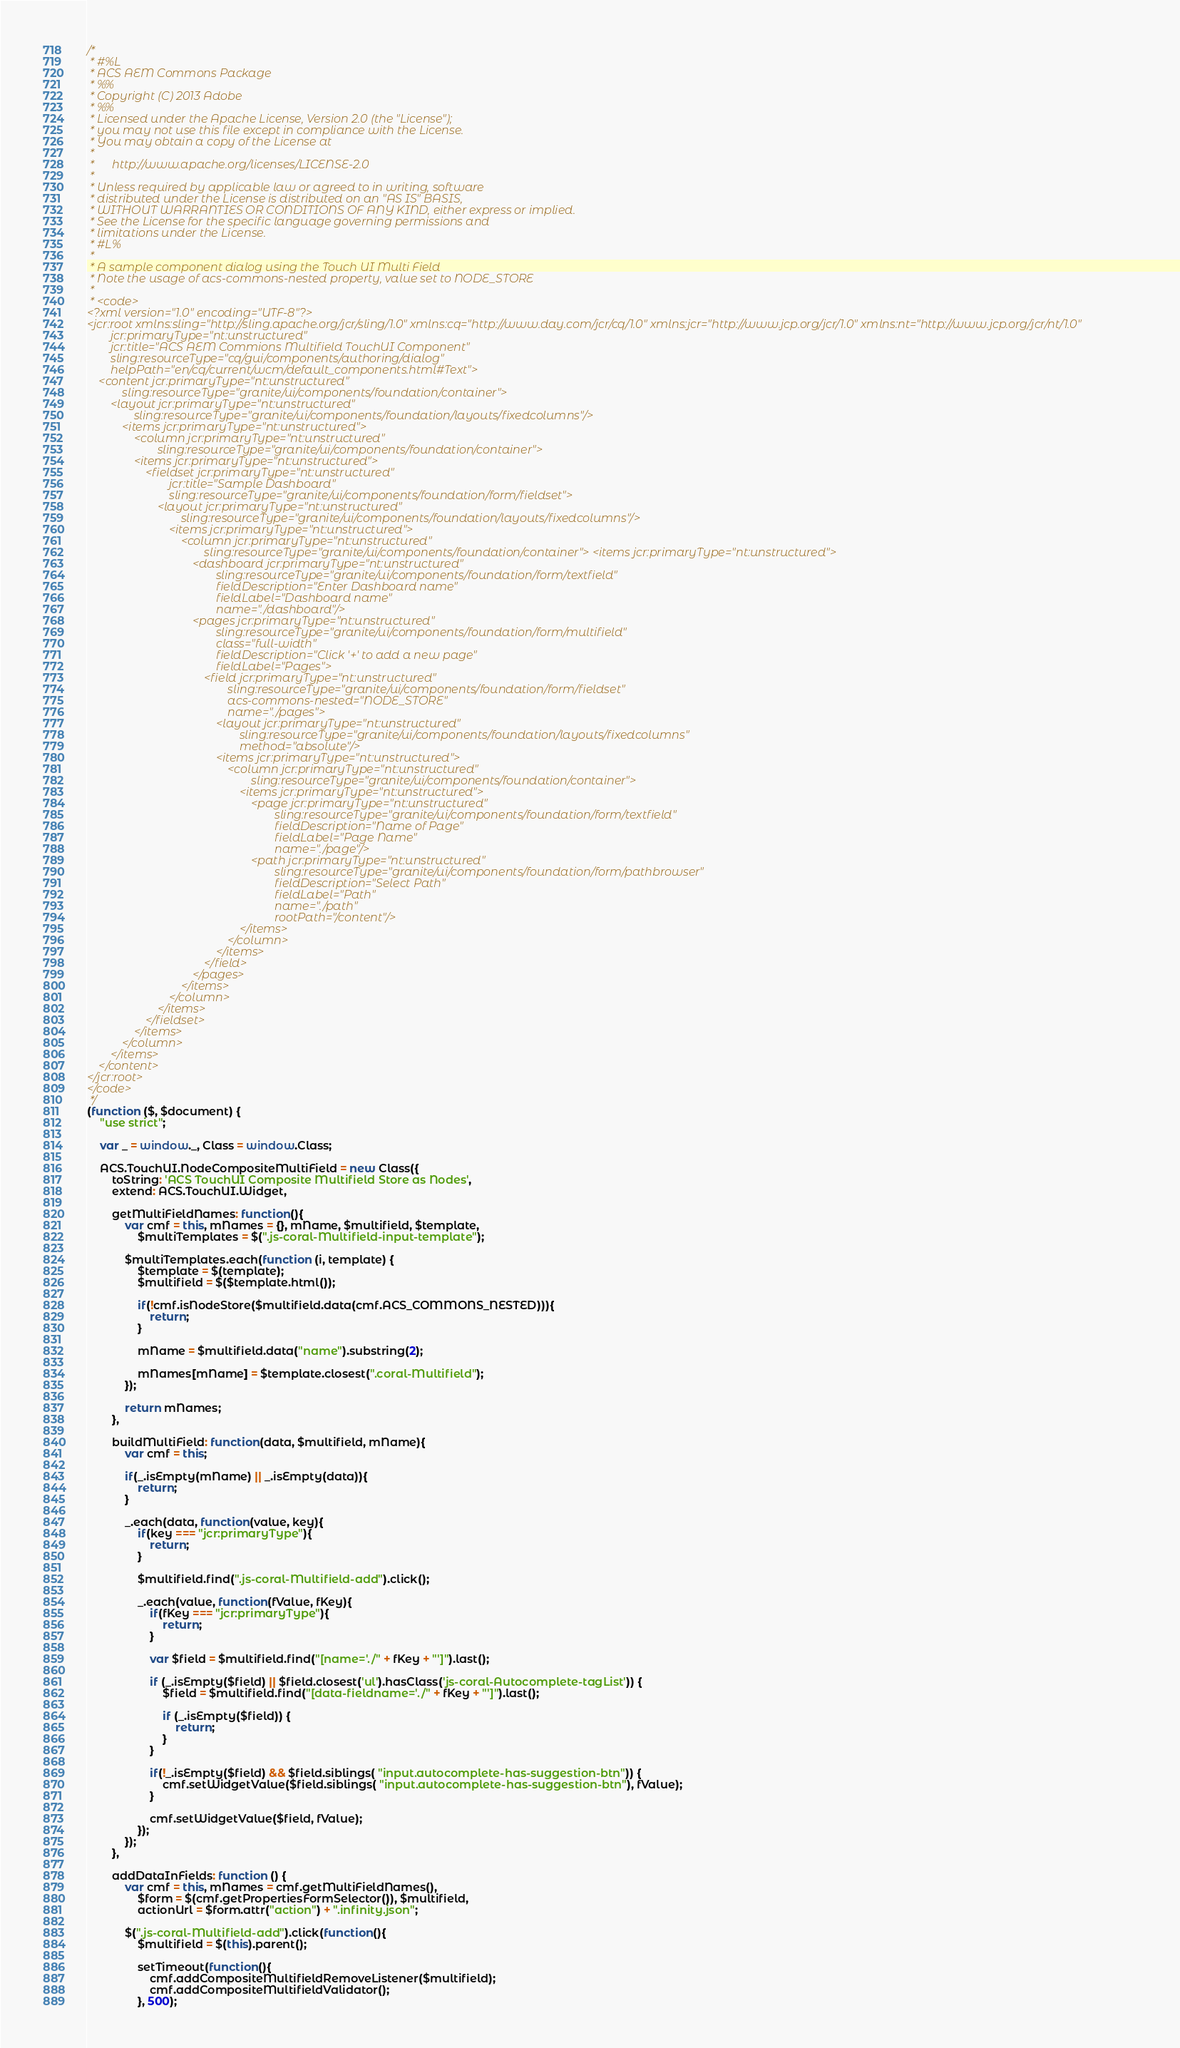<code> <loc_0><loc_0><loc_500><loc_500><_JavaScript_>/*
 * #%L
 * ACS AEM Commons Package
 * %%
 * Copyright (C) 2013 Adobe
 * %%
 * Licensed under the Apache License, Version 2.0 (the "License");
 * you may not use this file except in compliance with the License.
 * You may obtain a copy of the License at
 *
 *      http://www.apache.org/licenses/LICENSE-2.0
 *
 * Unless required by applicable law or agreed to in writing, software
 * distributed under the License is distributed on an "AS IS" BASIS,
 * WITHOUT WARRANTIES OR CONDITIONS OF ANY KIND, either express or implied.
 * See the License for the specific language governing permissions and
 * limitations under the License.
 * #L%
 *
 * A sample component dialog using the Touch UI Multi Field
 * Note the usage of acs-commons-nested property, value set to NODE_STORE
 *
 * <code>
<?xml version="1.0" encoding="UTF-8"?>
<jcr:root xmlns:sling="http://sling.apache.org/jcr/sling/1.0" xmlns:cq="http://www.day.com/jcr/cq/1.0" xmlns:jcr="http://www.jcp.org/jcr/1.0" xmlns:nt="http://www.jcp.org/jcr/nt/1.0"
        jcr:primaryType="nt:unstructured"
        jcr:title="ACS AEM Commions Multifield TouchUI Component"
        sling:resourceType="cq/gui/components/authoring/dialog"
        helpPath="en/cq/current/wcm/default_components.html#Text">
    <content jcr:primaryType="nt:unstructured"
            sling:resourceType="granite/ui/components/foundation/container">
        <layout jcr:primaryType="nt:unstructured"
                sling:resourceType="granite/ui/components/foundation/layouts/fixedcolumns"/>
            <items jcr:primaryType="nt:unstructured">
                <column jcr:primaryType="nt:unstructured"
                        sling:resourceType="granite/ui/components/foundation/container">
                <items jcr:primaryType="nt:unstructured">
                    <fieldset jcr:primaryType="nt:unstructured"
                            jcr:title="Sample Dashboard"
                            sling:resourceType="granite/ui/components/foundation/form/fieldset">
                        <layout jcr:primaryType="nt:unstructured"
                                sling:resourceType="granite/ui/components/foundation/layouts/fixedcolumns"/>
                            <items jcr:primaryType="nt:unstructured">
                                <column jcr:primaryType="nt:unstructured"
                                        sling:resourceType="granite/ui/components/foundation/container"> <items jcr:primaryType="nt:unstructured">
                                    <dashboard jcr:primaryType="nt:unstructured"
                                            sling:resourceType="granite/ui/components/foundation/form/textfield"
                                            fieldDescription="Enter Dashboard name"
                                            fieldLabel="Dashboard name"
                                            name="./dashboard"/>
                                    <pages jcr:primaryType="nt:unstructured"
                                            sling:resourceType="granite/ui/components/foundation/form/multifield"
                                            class="full-width"
                                            fieldDescription="Click '+' to add a new page"
                                            fieldLabel="Pages">
                                        <field jcr:primaryType="nt:unstructured"
                                                sling:resourceType="granite/ui/components/foundation/form/fieldset"
                                                acs-commons-nested="NODE_STORE"
                                                name="./pages">
                                            <layout jcr:primaryType="nt:unstructured"
                                                    sling:resourceType="granite/ui/components/foundation/layouts/fixedcolumns"
                                                    method="absolute"/>
                                            <items jcr:primaryType="nt:unstructured">
                                                <column jcr:primaryType="nt:unstructured"
                                                        sling:resourceType="granite/ui/components/foundation/container">
                                                    <items jcr:primaryType="nt:unstructured">
                                                        <page jcr:primaryType="nt:unstructured"
                                                                sling:resourceType="granite/ui/components/foundation/form/textfield"
                                                                fieldDescription="Name of Page"
                                                                fieldLabel="Page Name"
                                                                name="./page"/>
                                                        <path jcr:primaryType="nt:unstructured"
                                                                sling:resourceType="granite/ui/components/foundation/form/pathbrowser"
                                                                fieldDescription="Select Path"
                                                                fieldLabel="Path"
                                                                name="./path"
                                                                rootPath="/content"/>
                                                    </items>
                                                </column>
                                            </items>
                                        </field>
                                    </pages>
                                </items>
                            </column>
                        </items>
                    </fieldset>
                </items>
            </column>
        </items>
    </content>
</jcr:root>
</code>
 */
(function ($, $document) {
    "use strict";

    var _ = window._, Class = window.Class;

    ACS.TouchUI.NodeCompositeMultiField = new Class({
        toString: 'ACS TouchUI Composite Multifield Store as Nodes',
        extend: ACS.TouchUI.Widget,

        getMultiFieldNames: function(){
            var cmf = this, mNames = {}, mName, $multifield, $template,
                $multiTemplates = $(".js-coral-Multifield-input-template");

            $multiTemplates.each(function (i, template) {
                $template = $(template);
                $multifield = $($template.html());

                if(!cmf.isNodeStore($multifield.data(cmf.ACS_COMMONS_NESTED))){
                    return;
                }

                mName = $multifield.data("name").substring(2);

                mNames[mName] = $template.closest(".coral-Multifield");
            });

            return mNames;
        },

        buildMultiField: function(data, $multifield, mName){
            var cmf = this;

            if(_.isEmpty(mName) || _.isEmpty(data)){
                return;
            }

            _.each(data, function(value, key){
                if(key === "jcr:primaryType"){
                    return;
                }

                $multifield.find(".js-coral-Multifield-add").click();

                _.each(value, function(fValue, fKey){
                    if(fKey === "jcr:primaryType"){
                        return;
                    }

                    var $field = $multifield.find("[name='./" + fKey + "']").last();

                    if (_.isEmpty($field) || $field.closest('ul').hasClass('js-coral-Autocomplete-tagList')) {
                        $field = $multifield.find("[data-fieldname='./" + fKey + "']").last();

                        if (_.isEmpty($field)) {
                            return;
                        }
                    }

                    if(!_.isEmpty($field) && $field.siblings( "input.autocomplete-has-suggestion-btn")) {
                        cmf.setWidgetValue($field.siblings( "input.autocomplete-has-suggestion-btn"), fValue);
                    }

                    cmf.setWidgetValue($field, fValue);
                });
            });
        },

        addDataInFields: function () {
            var cmf = this, mNames = cmf.getMultiFieldNames(),
                $form = $(cmf.getPropertiesFormSelector()), $multifield,
                actionUrl = $form.attr("action") + ".infinity.json";

            $(".js-coral-Multifield-add").click(function(){
                $multifield = $(this).parent();

                setTimeout(function(){
                    cmf.addCompositeMultifieldRemoveListener($multifield);
                    cmf.addCompositeMultifieldValidator();
                }, 500);</code> 